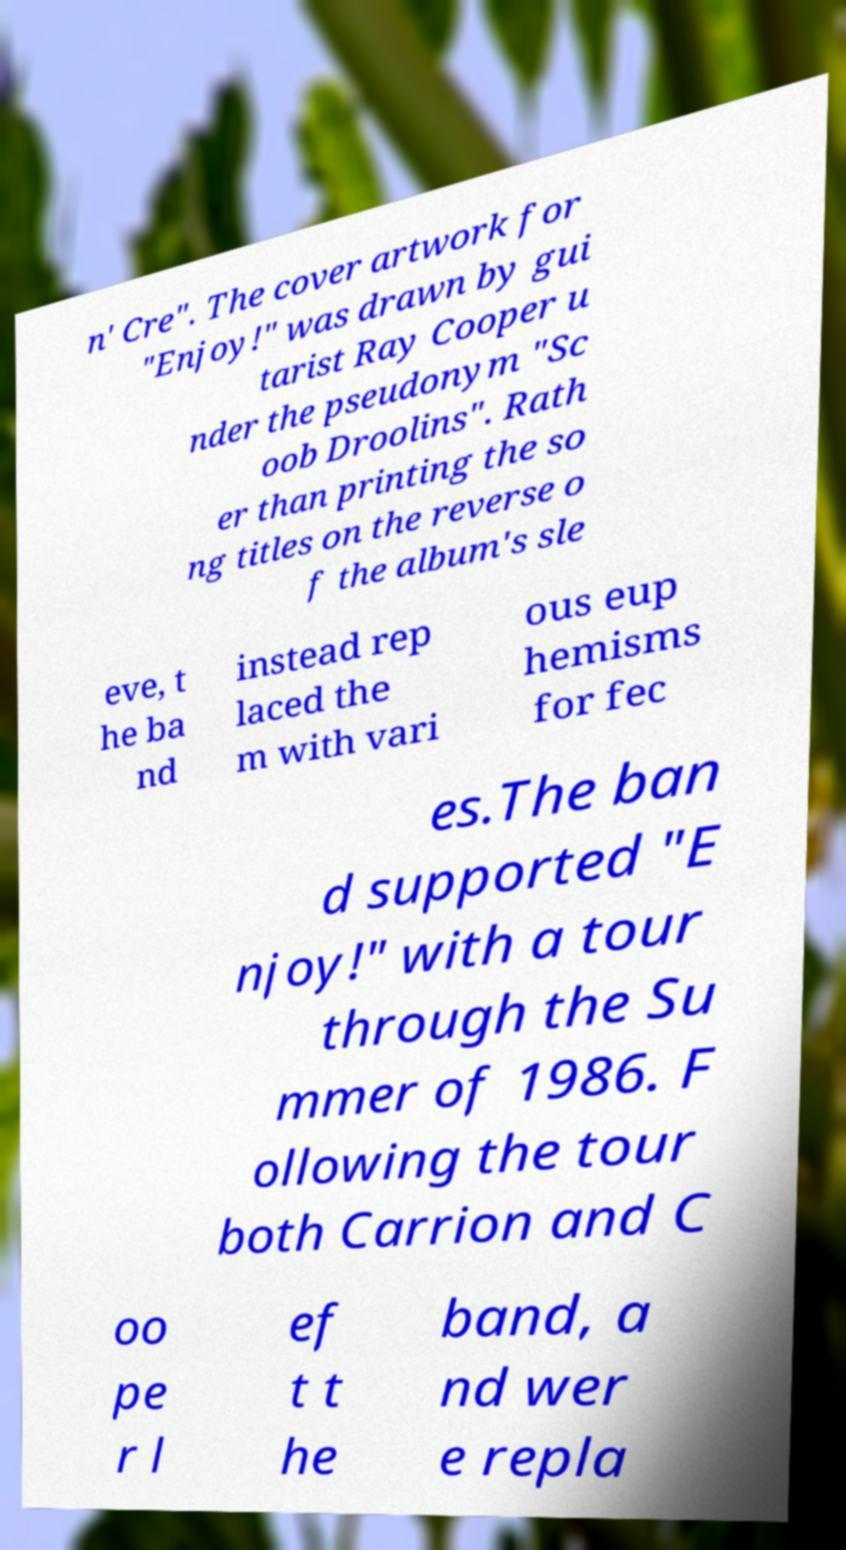There's text embedded in this image that I need extracted. Can you transcribe it verbatim? n' Cre". The cover artwork for "Enjoy!" was drawn by gui tarist Ray Cooper u nder the pseudonym "Sc oob Droolins". Rath er than printing the so ng titles on the reverse o f the album's sle eve, t he ba nd instead rep laced the m with vari ous eup hemisms for fec es.The ban d supported "E njoy!" with a tour through the Su mmer of 1986. F ollowing the tour both Carrion and C oo pe r l ef t t he band, a nd wer e repla 